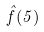<formula> <loc_0><loc_0><loc_500><loc_500>\hat { f } ( 5 )</formula> 